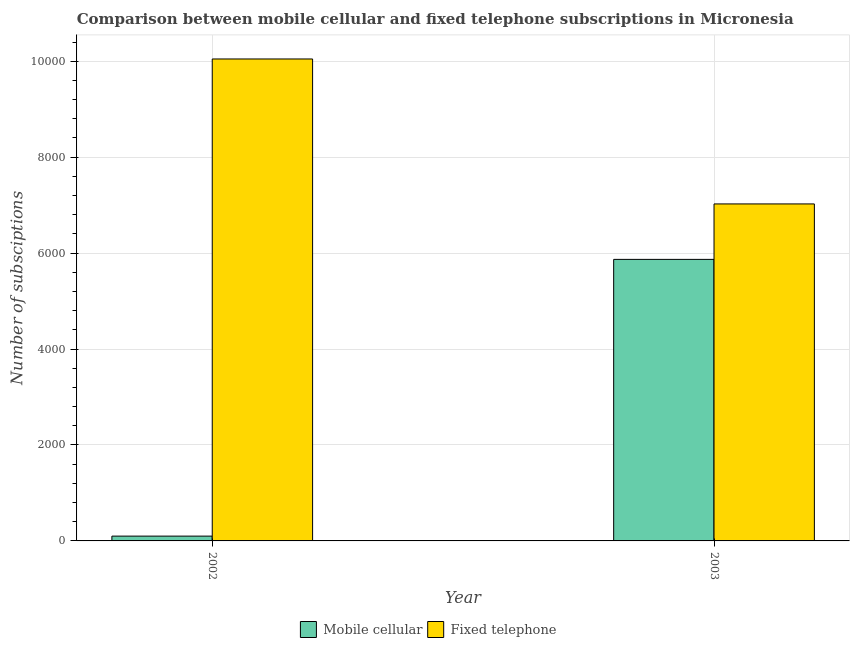How many different coloured bars are there?
Make the answer very short. 2. How many groups of bars are there?
Keep it short and to the point. 2. Are the number of bars on each tick of the X-axis equal?
Your answer should be very brief. Yes. How many bars are there on the 1st tick from the left?
Offer a very short reply. 2. How many bars are there on the 2nd tick from the right?
Your response must be concise. 2. What is the number of fixed telephone subscriptions in 2003?
Your answer should be compact. 7025. Across all years, what is the maximum number of mobile cellular subscriptions?
Offer a terse response. 5869. Across all years, what is the minimum number of fixed telephone subscriptions?
Make the answer very short. 7025. In which year was the number of fixed telephone subscriptions maximum?
Ensure brevity in your answer.  2002. What is the total number of mobile cellular subscriptions in the graph?
Provide a short and direct response. 5969. What is the difference between the number of fixed telephone subscriptions in 2002 and that in 2003?
Provide a succinct answer. 3022. What is the difference between the number of fixed telephone subscriptions in 2003 and the number of mobile cellular subscriptions in 2002?
Provide a succinct answer. -3022. What is the average number of mobile cellular subscriptions per year?
Give a very brief answer. 2984.5. What is the ratio of the number of fixed telephone subscriptions in 2002 to that in 2003?
Provide a succinct answer. 1.43. Is the number of fixed telephone subscriptions in 2002 less than that in 2003?
Make the answer very short. No. What does the 2nd bar from the left in 2003 represents?
Provide a succinct answer. Fixed telephone. What does the 1st bar from the right in 2002 represents?
Your answer should be very brief. Fixed telephone. How many years are there in the graph?
Offer a terse response. 2. What is the difference between two consecutive major ticks on the Y-axis?
Keep it short and to the point. 2000. Does the graph contain grids?
Provide a succinct answer. Yes. Where does the legend appear in the graph?
Your answer should be very brief. Bottom center. How many legend labels are there?
Your answer should be compact. 2. How are the legend labels stacked?
Offer a terse response. Horizontal. What is the title of the graph?
Provide a short and direct response. Comparison between mobile cellular and fixed telephone subscriptions in Micronesia. Does "Resident workers" appear as one of the legend labels in the graph?
Offer a terse response. No. What is the label or title of the Y-axis?
Your answer should be compact. Number of subsciptions. What is the Number of subsciptions in Fixed telephone in 2002?
Provide a short and direct response. 1.00e+04. What is the Number of subsciptions in Mobile cellular in 2003?
Give a very brief answer. 5869. What is the Number of subsciptions in Fixed telephone in 2003?
Provide a succinct answer. 7025. Across all years, what is the maximum Number of subsciptions of Mobile cellular?
Provide a short and direct response. 5869. Across all years, what is the maximum Number of subsciptions of Fixed telephone?
Give a very brief answer. 1.00e+04. Across all years, what is the minimum Number of subsciptions of Fixed telephone?
Give a very brief answer. 7025. What is the total Number of subsciptions of Mobile cellular in the graph?
Your answer should be compact. 5969. What is the total Number of subsciptions in Fixed telephone in the graph?
Make the answer very short. 1.71e+04. What is the difference between the Number of subsciptions in Mobile cellular in 2002 and that in 2003?
Your response must be concise. -5769. What is the difference between the Number of subsciptions in Fixed telephone in 2002 and that in 2003?
Keep it short and to the point. 3022. What is the difference between the Number of subsciptions in Mobile cellular in 2002 and the Number of subsciptions in Fixed telephone in 2003?
Your response must be concise. -6925. What is the average Number of subsciptions in Mobile cellular per year?
Keep it short and to the point. 2984.5. What is the average Number of subsciptions of Fixed telephone per year?
Keep it short and to the point. 8536. In the year 2002, what is the difference between the Number of subsciptions of Mobile cellular and Number of subsciptions of Fixed telephone?
Provide a short and direct response. -9947. In the year 2003, what is the difference between the Number of subsciptions of Mobile cellular and Number of subsciptions of Fixed telephone?
Your response must be concise. -1156. What is the ratio of the Number of subsciptions in Mobile cellular in 2002 to that in 2003?
Offer a very short reply. 0.02. What is the ratio of the Number of subsciptions in Fixed telephone in 2002 to that in 2003?
Your answer should be compact. 1.43. What is the difference between the highest and the second highest Number of subsciptions of Mobile cellular?
Offer a very short reply. 5769. What is the difference between the highest and the second highest Number of subsciptions of Fixed telephone?
Offer a very short reply. 3022. What is the difference between the highest and the lowest Number of subsciptions of Mobile cellular?
Offer a terse response. 5769. What is the difference between the highest and the lowest Number of subsciptions of Fixed telephone?
Provide a short and direct response. 3022. 